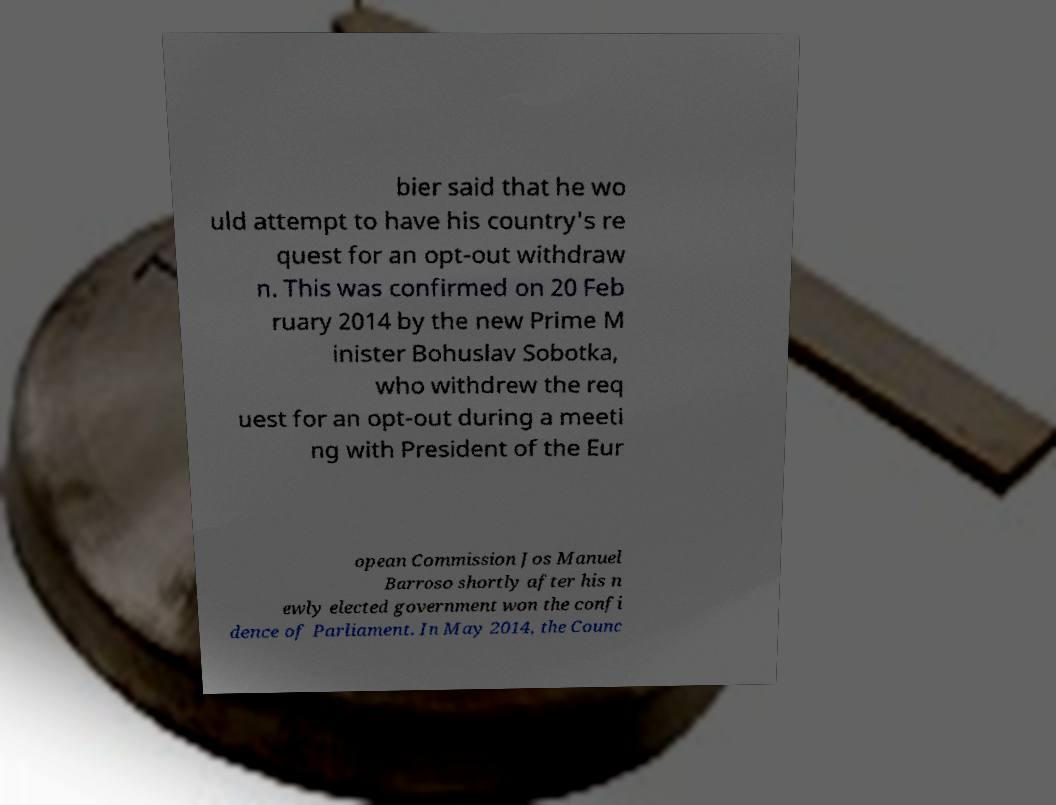I need the written content from this picture converted into text. Can you do that? bier said that he wo uld attempt to have his country's re quest for an opt-out withdraw n. This was confirmed on 20 Feb ruary 2014 by the new Prime M inister Bohuslav Sobotka, who withdrew the req uest for an opt-out during a meeti ng with President of the Eur opean Commission Jos Manuel Barroso shortly after his n ewly elected government won the confi dence of Parliament. In May 2014, the Counc 